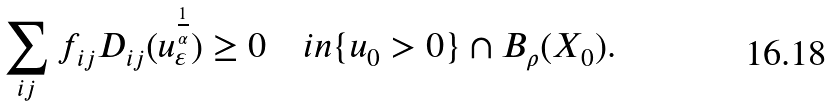<formula> <loc_0><loc_0><loc_500><loc_500>\sum _ { i j } f _ { i j } D _ { i j } ( u _ { \varepsilon } ^ { \frac { 1 } { \alpha } } ) \geq 0 \quad i n \{ u _ { 0 } > 0 \} \cap B _ { \rho } ( X _ { 0 } ) .</formula> 